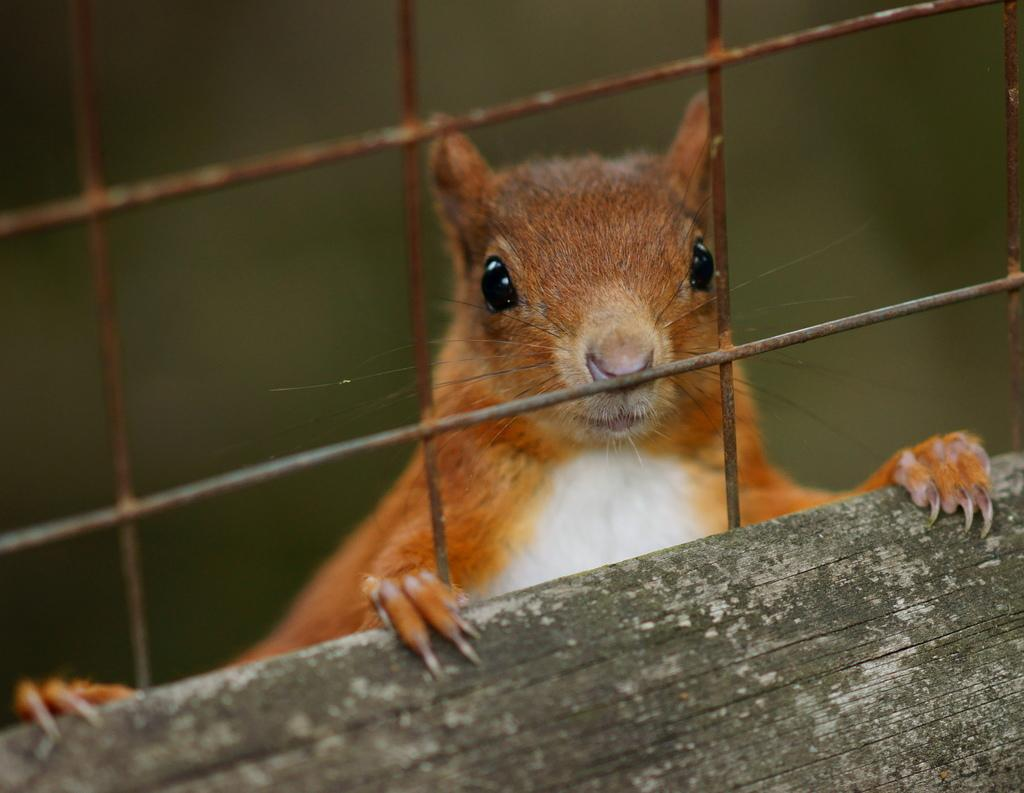What type of creature is present in the image? There is an animal in the image. What is the animal doing in the image? The animal is holding a wooden object. What other object can be seen in the image? There is a welded mesh wire in the image. Can you describe the background of the image? The background of the image is blurry. How many trees can be seen in the image? There are no trees visible in the image. Can you describe the bee's behavior in the image? There is no bee present in the image. 